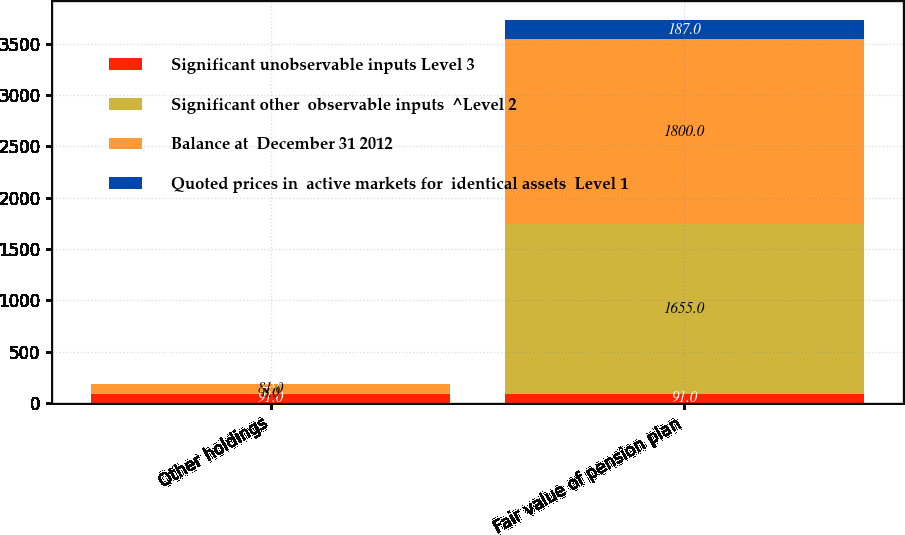<chart> <loc_0><loc_0><loc_500><loc_500><stacked_bar_chart><ecel><fcel>Other holdings<fcel>Fair value of pension plan<nl><fcel>Significant unobservable inputs Level 3<fcel>91<fcel>91<nl><fcel>Significant other  observable inputs  ^Level 2<fcel>8<fcel>1655<nl><fcel>Balance at  December 31 2012<fcel>81<fcel>1800<nl><fcel>Quoted prices in  active markets for  identical assets  Level 1<fcel>2<fcel>187<nl></chart> 